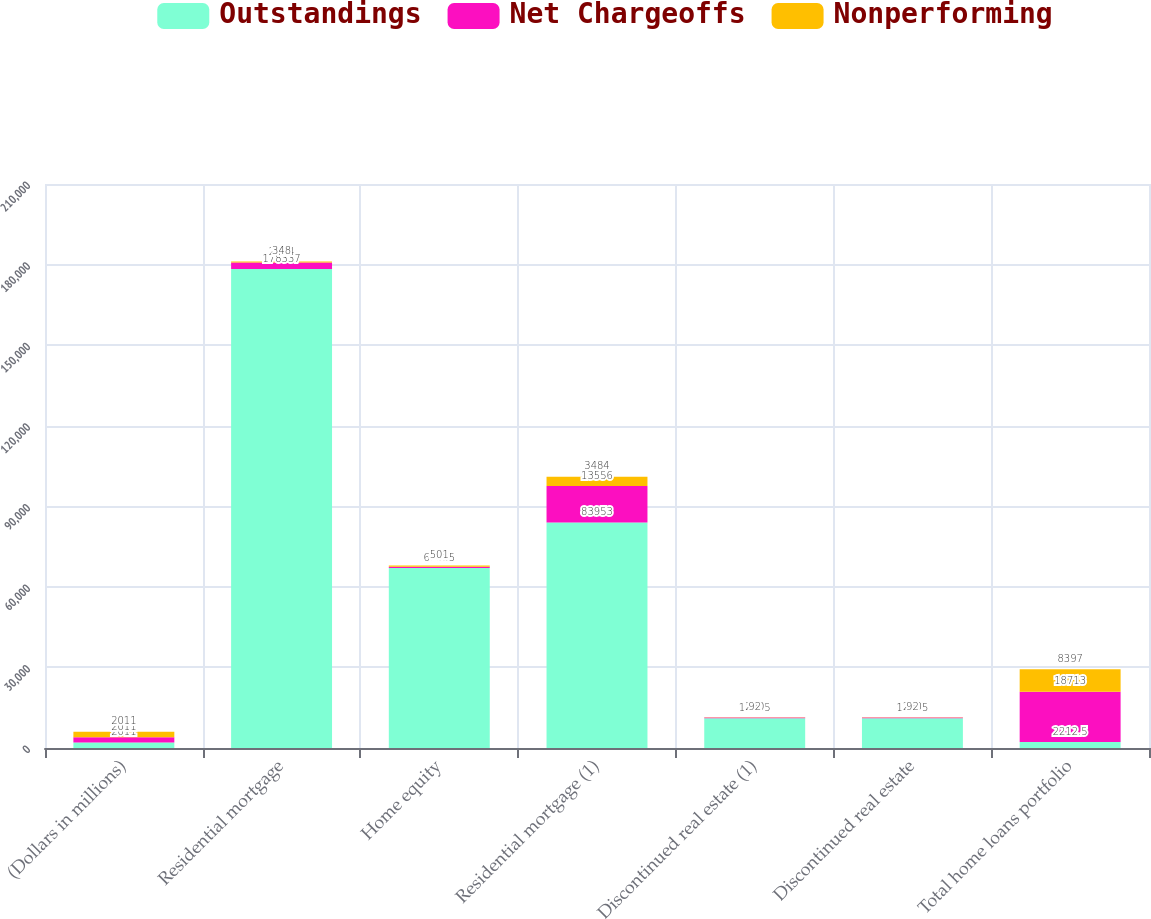Convert chart to OTSL. <chart><loc_0><loc_0><loc_500><loc_500><stacked_bar_chart><ecel><fcel>(Dollars in millions)<fcel>Residential mortgage<fcel>Home equity<fcel>Residential mortgage (1)<fcel>Discontinued real estate (1)<fcel>Discontinued real estate<fcel>Total home loans portfolio<nl><fcel>Outstandings<fcel>2011<fcel>178337<fcel>67055<fcel>83953<fcel>11095<fcel>11095<fcel>2212.5<nl><fcel>Net Chargeoffs<fcel>2011<fcel>2414<fcel>439<fcel>13556<fcel>290<fcel>290<fcel>18713<nl><fcel>Nonperforming<fcel>2011<fcel>348<fcel>501<fcel>3484<fcel>92<fcel>92<fcel>8397<nl></chart> 